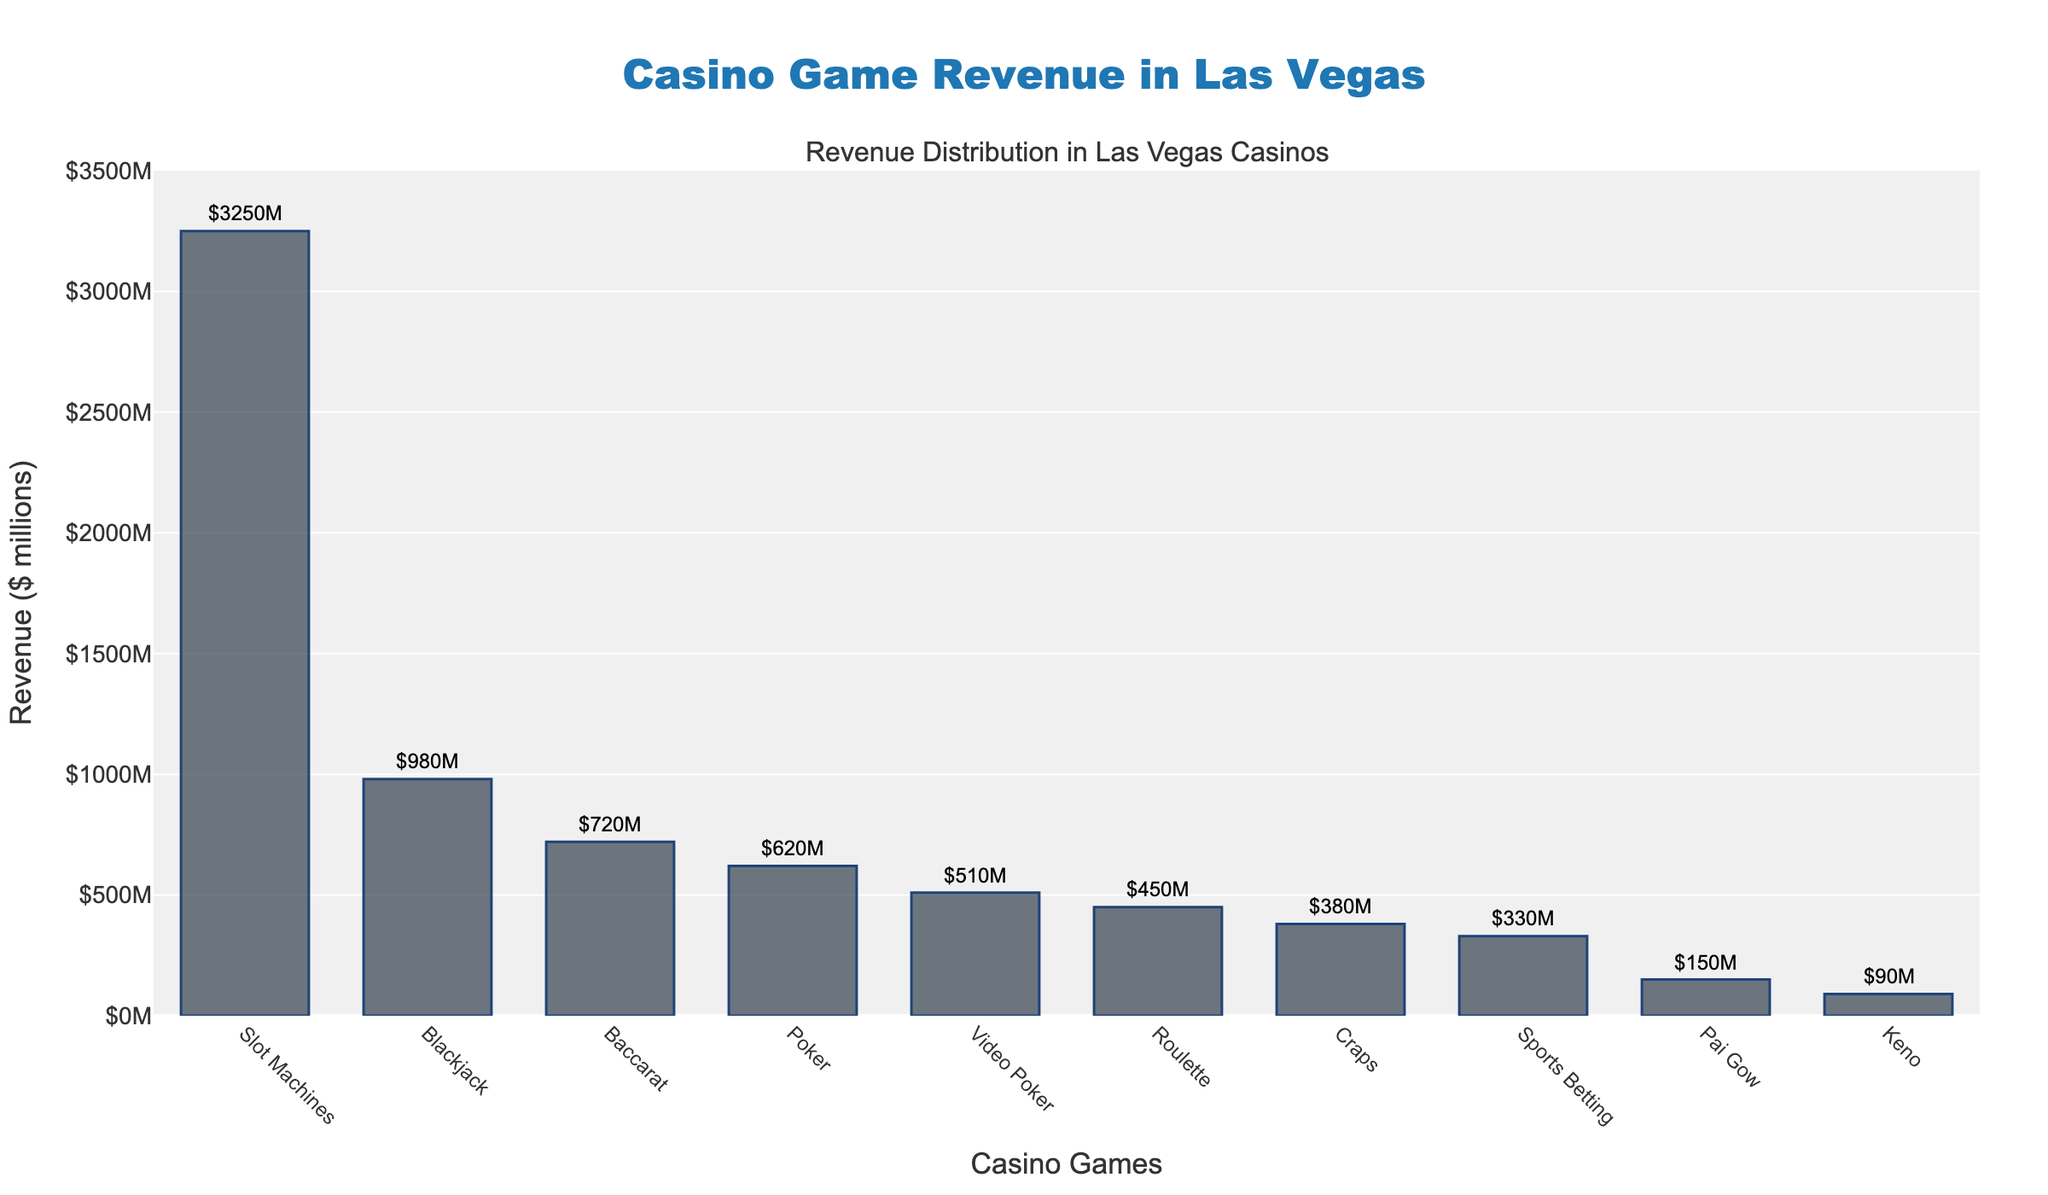Which casino game generates the highest revenue? The bar chart shows that Slot Machines have the tallest bar, indicating the highest revenue among all the games listed.
Answer: Slot Machines What is the total revenue generated by Poker and Baccarat combined? The revenue for Poker is $620 million, and for Baccarat, it’s $720 million. Adding these together: $620M + $720M = $1340M.
Answer: $1340M How does the revenue from Roulette compare to that from Sports Betting? The bar for Roulette is taller than the one for Sports Betting. The revenue for Roulette is $450 million, while for Sports Betting, it’s $330 million. Thus, Roulette generates more revenue than Sports Betting.
Answer: Roulette generates more Which has a lower revenue, Keno or Pai Gow? The bar for Keno is shorter than the one for Pai Gow. Keno has a revenue of $90 million, while Pai Gow has $150 million.
Answer: Keno What is the average revenue of Craps, Video Poker, and Sports Betting? The revenues are: Craps $380M, Video Poker $510M, and Sports Betting $330M. The sum is $380M + $510M + $330M = $1220M. The average is $1220M / 3 = $406.67M.
Answer: $406.67M What is the difference in revenue between the highest and lowest-grossing casino games? The revenue for Slot Machines (highest) is $3250 million, and the revenue for Keno (lowest) is $90 million. The difference is $3250M - $90M = $3160M.
Answer: $3160M Which casino games generate more than $500 million in revenue? The bars for Slot Machines, Blackjack, Poker, and Baccarat are higher than the $500M mark. Their revenues are: Slot Machines $3250M, Blackjack $980M, Poker $620M, and Baccarat $720M.
Answer: Slot Machines, Blackjack, Poker, Baccarat Is the revenue from Video Poker higher than from Poker? The bar for Poker is taller than that for Video Poker. Poker's revenue is $620 million, while Video Poker's revenue is $510 million, indicating Poker generates more revenue.
Answer: No What is the revenue difference between Poker and Craps? The revenue for Poker is $620 million, and for Craps, it’s $380 million. The difference is $620M - $380M = $240M.
Answer: $240M 